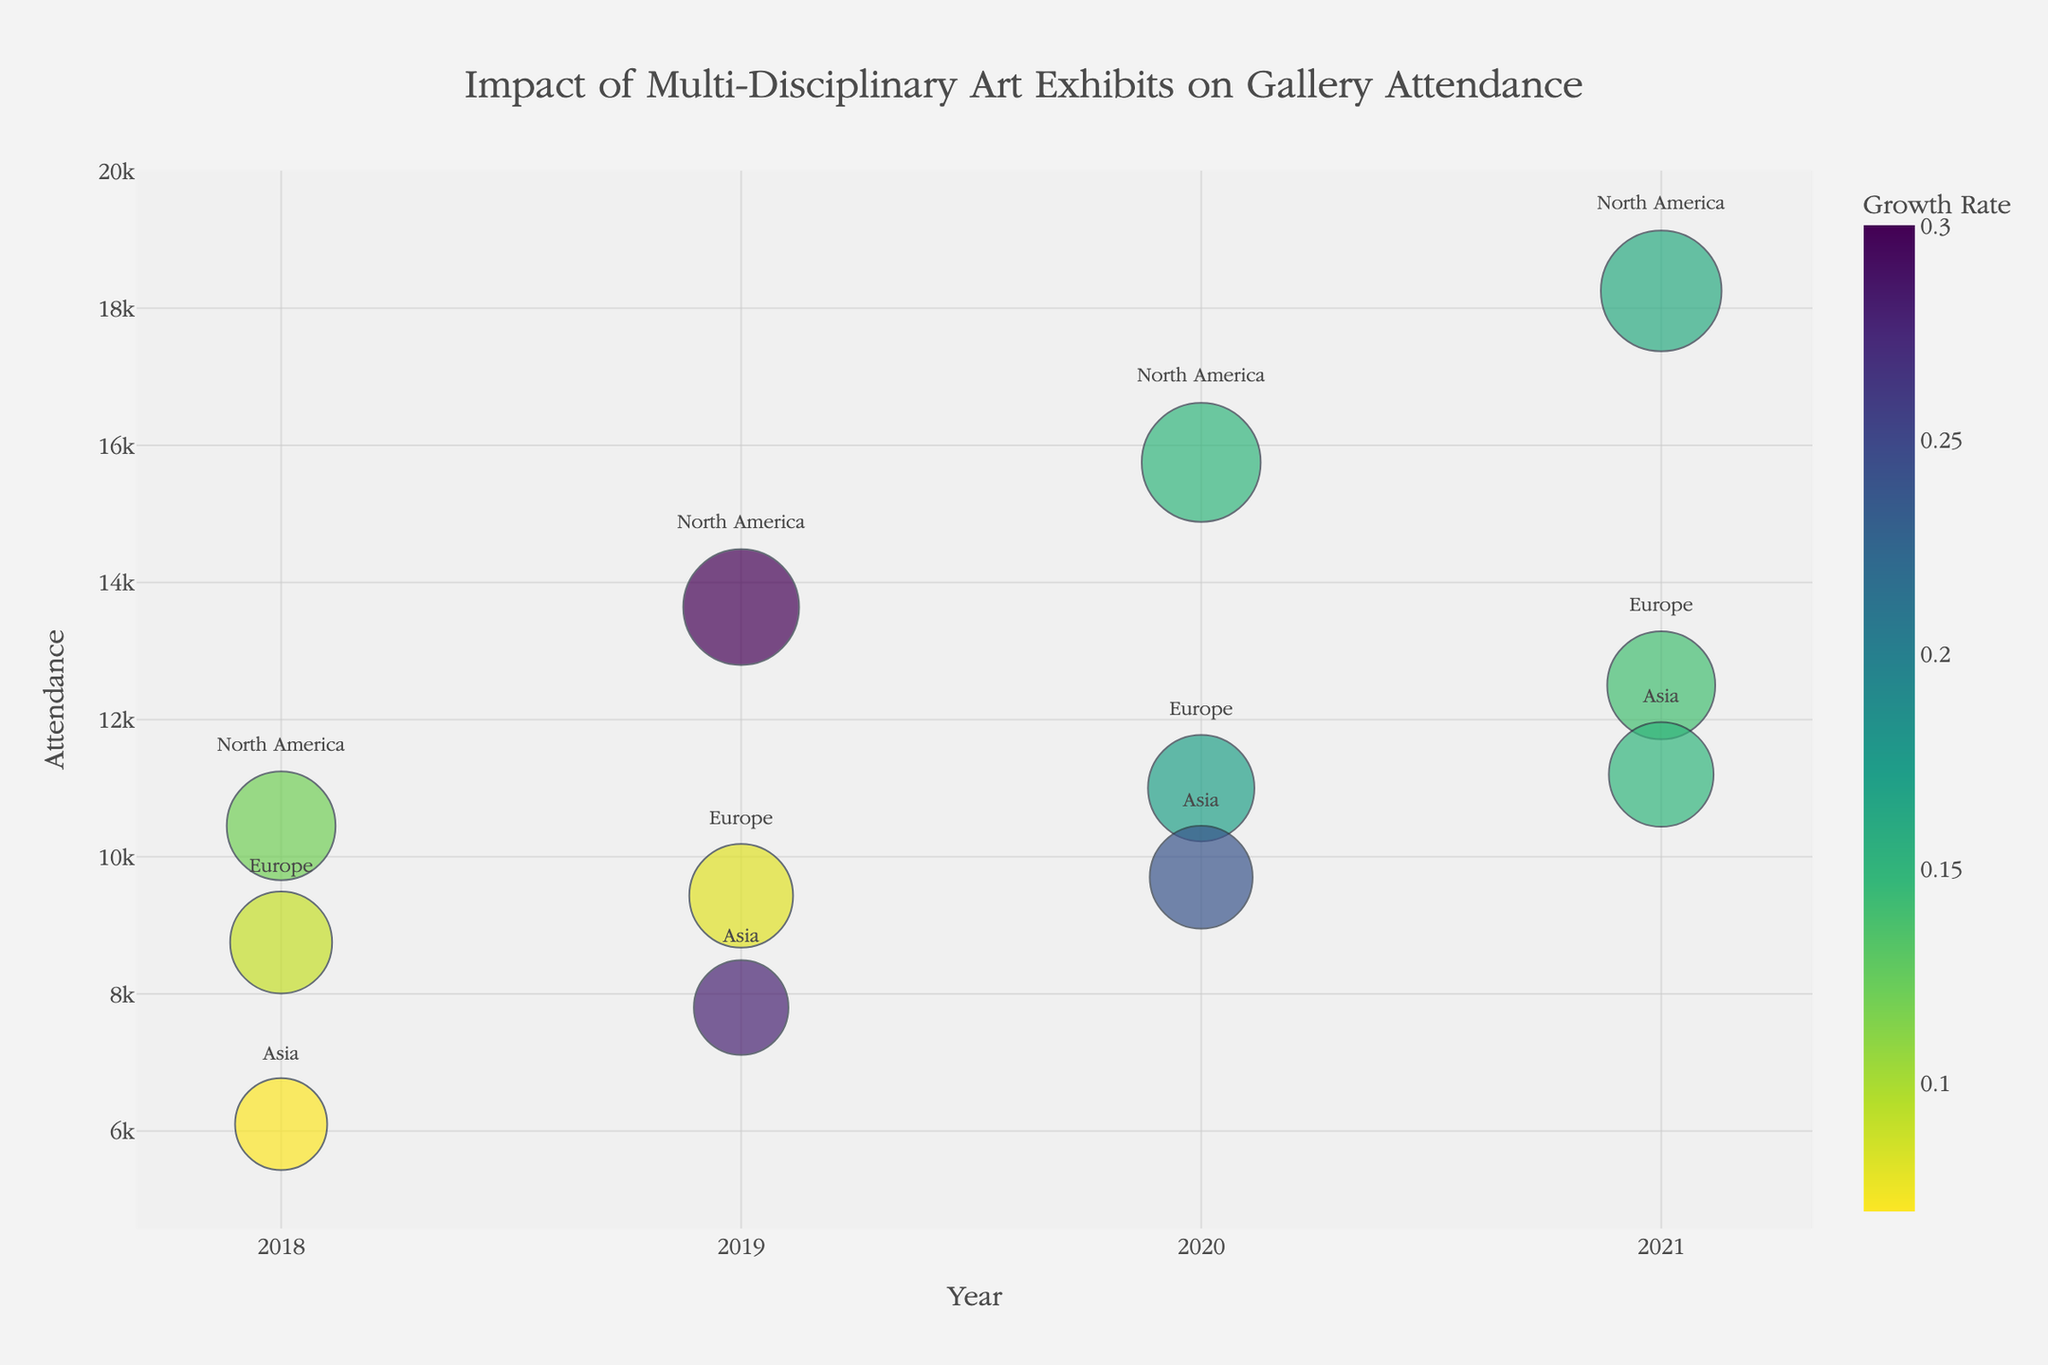How many regions and years are depicted in the bubble chart? The chart shows different data points for various regions across several years. From the provided information, the years range from 2018 to 2021, and the regions included are North America, Europe, and Asia.
Answer: 3 regions and 4 years What is the highest gallery attendance recorded, and which exhibit and year does it belong to? To find the highest attendance, observe the y-axis for the highest data point. The highest attendance of 18,250 is for "Post-Human Narratives: AI in Art" in North America in 2021.
Answer: Post-Human Narratives: AI in Art in 2021 What exhibit in Asia had the highest growth rate, and in which year did it occur? To locate the highest growth rate exhibit in Asia, look for the largest colored bubble within the Asian region’s bubbles. The exhibit "Urban Ephemerality: Street Art and Augmented Reality" in 2019 had the highest growth rate of 0.28.
Answer: Urban Ephemerality: Street Art and Augmented Reality in 2019 Between 2018 and 2021, which region saw the most significant increase in gallery attendance overall? Compare the sizes and y-positions of the bubbles over the years for each region. North America shows the most notable increase in gallery attendance from 10,450 in 2018 to 18,250 in 2021.
Answer: North America Which exhibit had the smallest growth rate, and in which region and year was it observed? To find the smallest growth rate, look for the bubble with the smallest color intensity on the bubble chart. "Cinematic Symphonies: Film and Visual Art" in Europe in 2019 had the smallest growth rate of 0.08.
Answer: Cinematic Symphonies: Film and Visual Art in Europe in 2019 What was the total budget in USD for North American exhibits from 2018 to 2021? Sum the budgets of all North American exhibits from the given years: 35,000 (2018) + 45,000 (2019) + 50,000 (2020) + 53,000 (2021) = 183,000 USD.
Answer: 183,000 USD How does the budget size compare between "Collapse and Creation: Eco-Media Installations" in 2020 and "Future Artifacts: 3D Printed Histories" in 2020? Look at the size of the bubbles representing these exhibits. "Collapse and Creation: Eco-Media Installations" has a budget of 50,000 USD, which is larger compared to "Future Artifacts: 3D Printed Histories" with a budget of 28,000 USD.
Answer: Collapse and Creation: Eco-Media Installations had a larger budget What can be inferred about the relationship between budget and attendance based on the bubble chart? Reviewing the size and vertical position of the bubbles, larger budgets generally correspond to higher attendance, indicating a positive relationship between the two variables. For instance, "Post-Human Narratives: AI in Art" with the highest attendance also has one of the largest bubble sizes.
Answer: Larger budgets generally correspond to higher attendance 